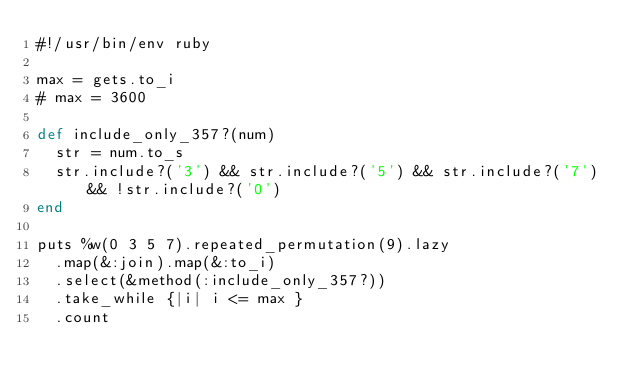Convert code to text. <code><loc_0><loc_0><loc_500><loc_500><_Ruby_>#!/usr/bin/env ruby

max = gets.to_i
# max = 3600

def include_only_357?(num)
  str = num.to_s
  str.include?('3') && str.include?('5') && str.include?('7') && !str.include?('0')
end

puts %w(0 3 5 7).repeated_permutation(9).lazy
  .map(&:join).map(&:to_i)
  .select(&method(:include_only_357?))
  .take_while {|i| i <= max }
  .count
</code> 